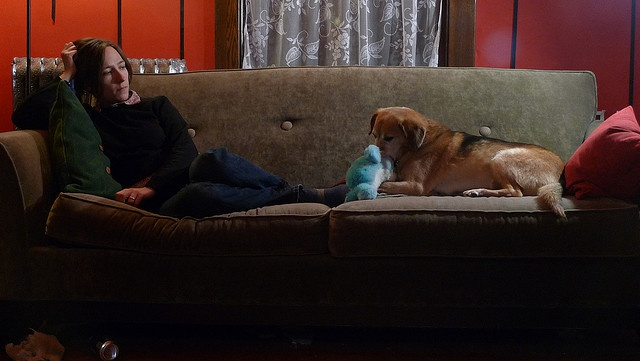Describe the objects in this image and their specific colors. I can see couch in red, black, gray, and maroon tones, people in red, black, maroon, gray, and brown tones, dog in red, maroon, black, gray, and brown tones, teddy bear in red, teal, black, and gray tones, and teddy bear in black, maroon, and red tones in this image. 